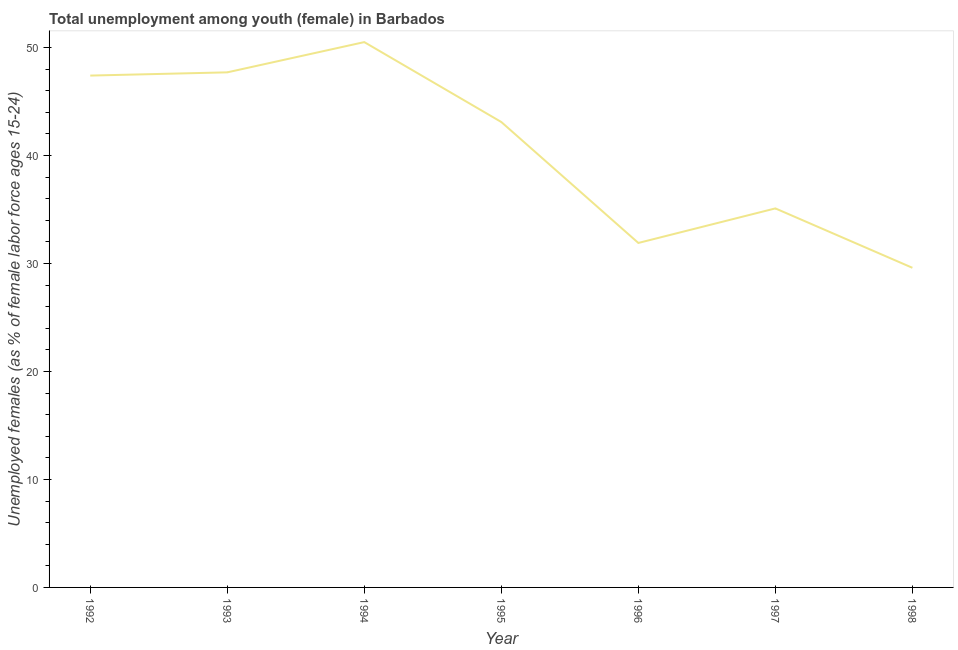What is the unemployed female youth population in 1998?
Your answer should be compact. 29.6. Across all years, what is the maximum unemployed female youth population?
Ensure brevity in your answer.  50.5. Across all years, what is the minimum unemployed female youth population?
Make the answer very short. 29.6. In which year was the unemployed female youth population maximum?
Keep it short and to the point. 1994. What is the sum of the unemployed female youth population?
Keep it short and to the point. 285.3. What is the difference between the unemployed female youth population in 1997 and 1998?
Your answer should be compact. 5.5. What is the average unemployed female youth population per year?
Your answer should be very brief. 40.76. What is the median unemployed female youth population?
Your response must be concise. 43.1. Do a majority of the years between 1996 and 1994 (inclusive) have unemployed female youth population greater than 16 %?
Keep it short and to the point. No. What is the ratio of the unemployed female youth population in 1996 to that in 1997?
Offer a terse response. 0.91. Is the difference between the unemployed female youth population in 1994 and 1995 greater than the difference between any two years?
Provide a succinct answer. No. What is the difference between the highest and the second highest unemployed female youth population?
Provide a succinct answer. 2.8. What is the difference between the highest and the lowest unemployed female youth population?
Offer a very short reply. 20.9. Does the unemployed female youth population monotonically increase over the years?
Provide a succinct answer. No. How many lines are there?
Your answer should be very brief. 1. How many years are there in the graph?
Provide a short and direct response. 7. Does the graph contain any zero values?
Offer a terse response. No. Does the graph contain grids?
Provide a short and direct response. No. What is the title of the graph?
Give a very brief answer. Total unemployment among youth (female) in Barbados. What is the label or title of the Y-axis?
Offer a very short reply. Unemployed females (as % of female labor force ages 15-24). What is the Unemployed females (as % of female labor force ages 15-24) in 1992?
Keep it short and to the point. 47.4. What is the Unemployed females (as % of female labor force ages 15-24) in 1993?
Provide a short and direct response. 47.7. What is the Unemployed females (as % of female labor force ages 15-24) of 1994?
Keep it short and to the point. 50.5. What is the Unemployed females (as % of female labor force ages 15-24) in 1995?
Provide a short and direct response. 43.1. What is the Unemployed females (as % of female labor force ages 15-24) in 1996?
Offer a very short reply. 31.9. What is the Unemployed females (as % of female labor force ages 15-24) of 1997?
Make the answer very short. 35.1. What is the Unemployed females (as % of female labor force ages 15-24) in 1998?
Your answer should be compact. 29.6. What is the difference between the Unemployed females (as % of female labor force ages 15-24) in 1992 and 1993?
Make the answer very short. -0.3. What is the difference between the Unemployed females (as % of female labor force ages 15-24) in 1992 and 1997?
Keep it short and to the point. 12.3. What is the difference between the Unemployed females (as % of female labor force ages 15-24) in 1993 and 1998?
Provide a succinct answer. 18.1. What is the difference between the Unemployed females (as % of female labor force ages 15-24) in 1994 and 1995?
Your answer should be very brief. 7.4. What is the difference between the Unemployed females (as % of female labor force ages 15-24) in 1994 and 1996?
Your answer should be compact. 18.6. What is the difference between the Unemployed females (as % of female labor force ages 15-24) in 1994 and 1998?
Offer a terse response. 20.9. What is the difference between the Unemployed females (as % of female labor force ages 15-24) in 1996 and 1997?
Keep it short and to the point. -3.2. What is the difference between the Unemployed females (as % of female labor force ages 15-24) in 1996 and 1998?
Your answer should be very brief. 2.3. What is the difference between the Unemployed females (as % of female labor force ages 15-24) in 1997 and 1998?
Provide a succinct answer. 5.5. What is the ratio of the Unemployed females (as % of female labor force ages 15-24) in 1992 to that in 1994?
Your response must be concise. 0.94. What is the ratio of the Unemployed females (as % of female labor force ages 15-24) in 1992 to that in 1996?
Offer a terse response. 1.49. What is the ratio of the Unemployed females (as % of female labor force ages 15-24) in 1992 to that in 1997?
Ensure brevity in your answer.  1.35. What is the ratio of the Unemployed females (as % of female labor force ages 15-24) in 1992 to that in 1998?
Provide a short and direct response. 1.6. What is the ratio of the Unemployed females (as % of female labor force ages 15-24) in 1993 to that in 1994?
Keep it short and to the point. 0.94. What is the ratio of the Unemployed females (as % of female labor force ages 15-24) in 1993 to that in 1995?
Keep it short and to the point. 1.11. What is the ratio of the Unemployed females (as % of female labor force ages 15-24) in 1993 to that in 1996?
Provide a succinct answer. 1.5. What is the ratio of the Unemployed females (as % of female labor force ages 15-24) in 1993 to that in 1997?
Give a very brief answer. 1.36. What is the ratio of the Unemployed females (as % of female labor force ages 15-24) in 1993 to that in 1998?
Offer a terse response. 1.61. What is the ratio of the Unemployed females (as % of female labor force ages 15-24) in 1994 to that in 1995?
Your response must be concise. 1.17. What is the ratio of the Unemployed females (as % of female labor force ages 15-24) in 1994 to that in 1996?
Provide a succinct answer. 1.58. What is the ratio of the Unemployed females (as % of female labor force ages 15-24) in 1994 to that in 1997?
Keep it short and to the point. 1.44. What is the ratio of the Unemployed females (as % of female labor force ages 15-24) in 1994 to that in 1998?
Provide a short and direct response. 1.71. What is the ratio of the Unemployed females (as % of female labor force ages 15-24) in 1995 to that in 1996?
Keep it short and to the point. 1.35. What is the ratio of the Unemployed females (as % of female labor force ages 15-24) in 1995 to that in 1997?
Give a very brief answer. 1.23. What is the ratio of the Unemployed females (as % of female labor force ages 15-24) in 1995 to that in 1998?
Your answer should be compact. 1.46. What is the ratio of the Unemployed females (as % of female labor force ages 15-24) in 1996 to that in 1997?
Provide a succinct answer. 0.91. What is the ratio of the Unemployed females (as % of female labor force ages 15-24) in 1996 to that in 1998?
Offer a terse response. 1.08. What is the ratio of the Unemployed females (as % of female labor force ages 15-24) in 1997 to that in 1998?
Give a very brief answer. 1.19. 